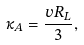Convert formula to latex. <formula><loc_0><loc_0><loc_500><loc_500>\kappa _ { A } = \frac { v R _ { L } } { 3 } ,</formula> 